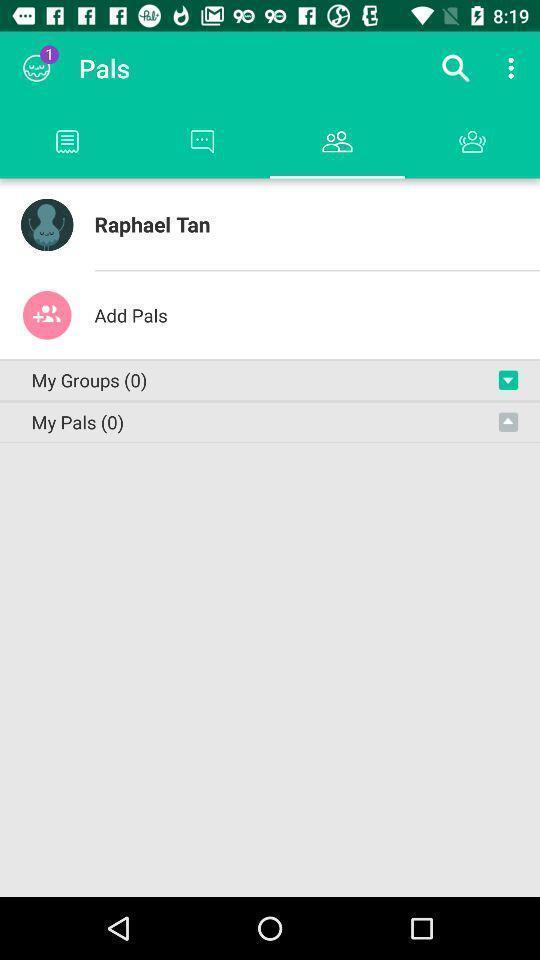Tell me about the visual elements in this screen capture. Screen page displaying the friend list. 